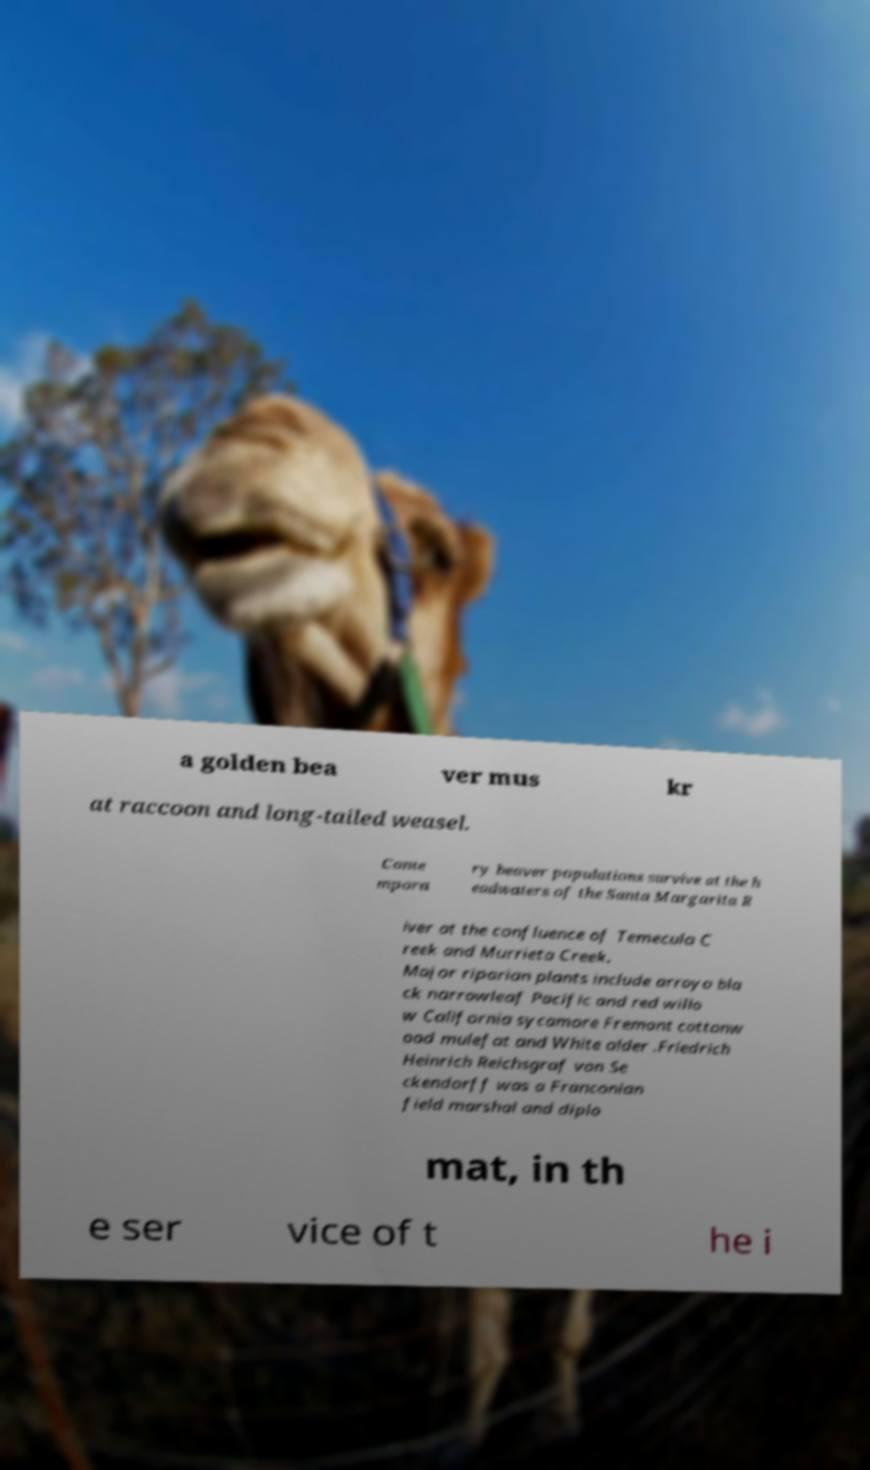Can you read and provide the text displayed in the image?This photo seems to have some interesting text. Can you extract and type it out for me? a golden bea ver mus kr at raccoon and long-tailed weasel. Conte mpora ry beaver populations survive at the h eadwaters of the Santa Margarita R iver at the confluence of Temecula C reek and Murrieta Creek. Major riparian plants include arroyo bla ck narrowleaf Pacific and red willo w California sycamore Fremont cottonw ood mulefat and White alder .Friedrich Heinrich Reichsgraf von Se ckendorff was a Franconian field marshal and diplo mat, in th e ser vice of t he i 